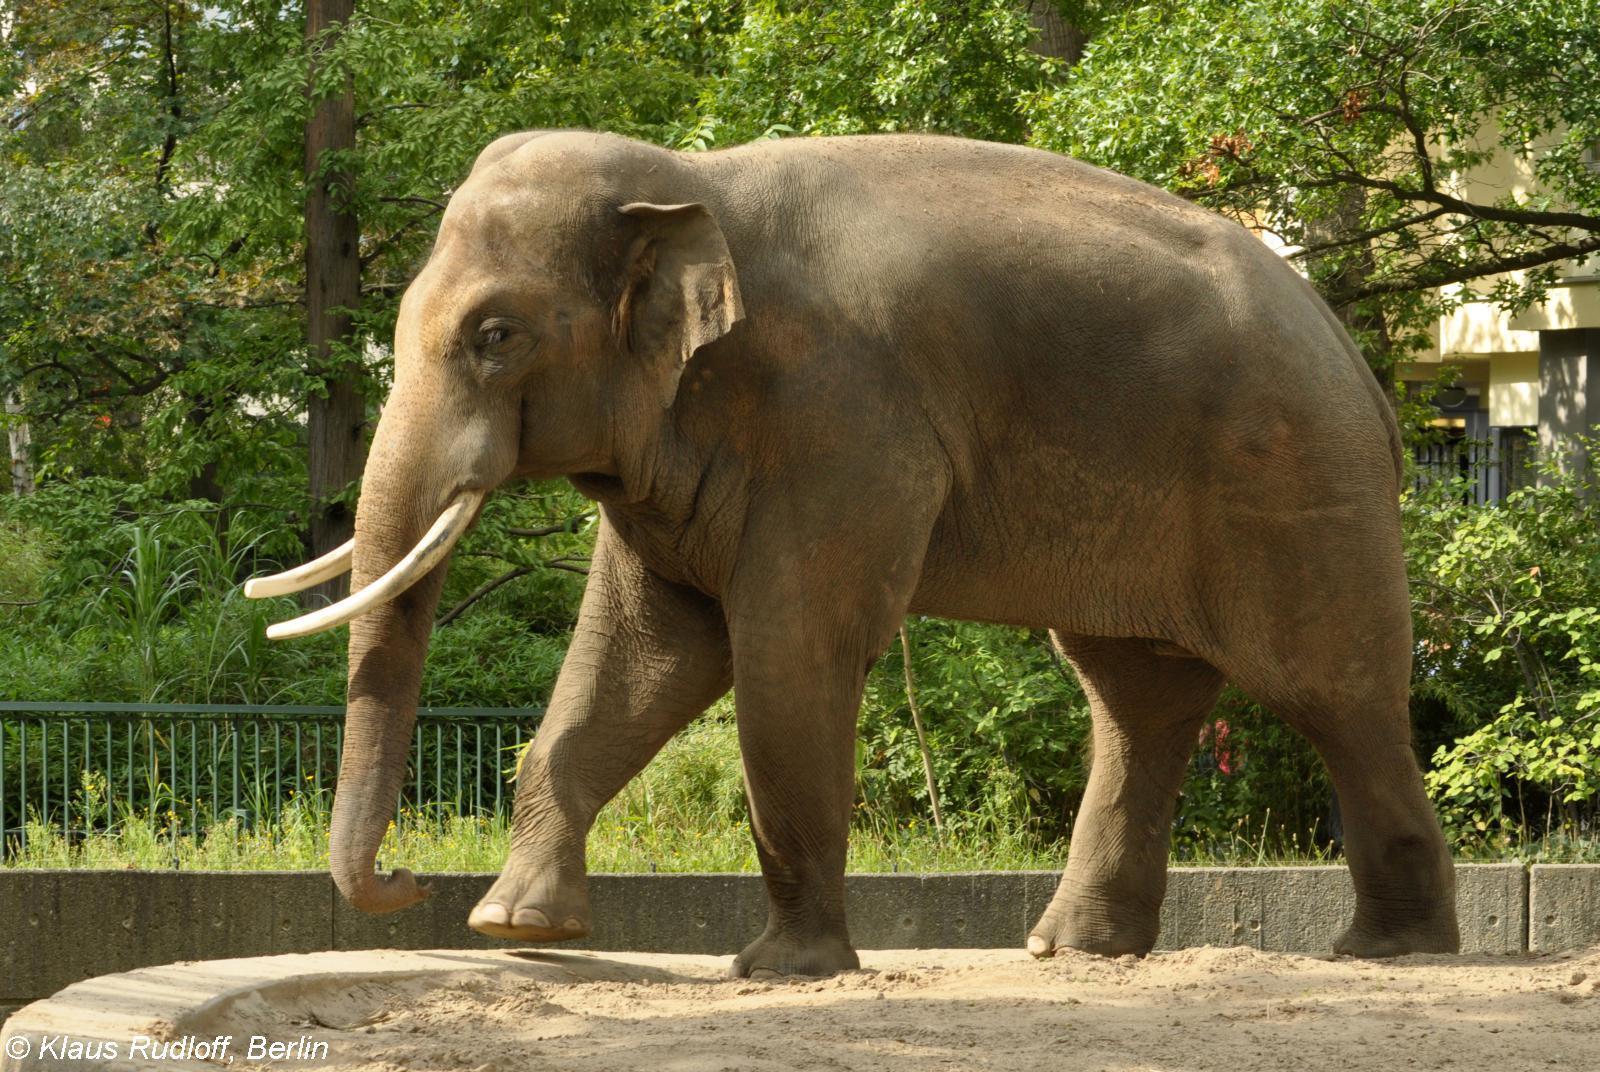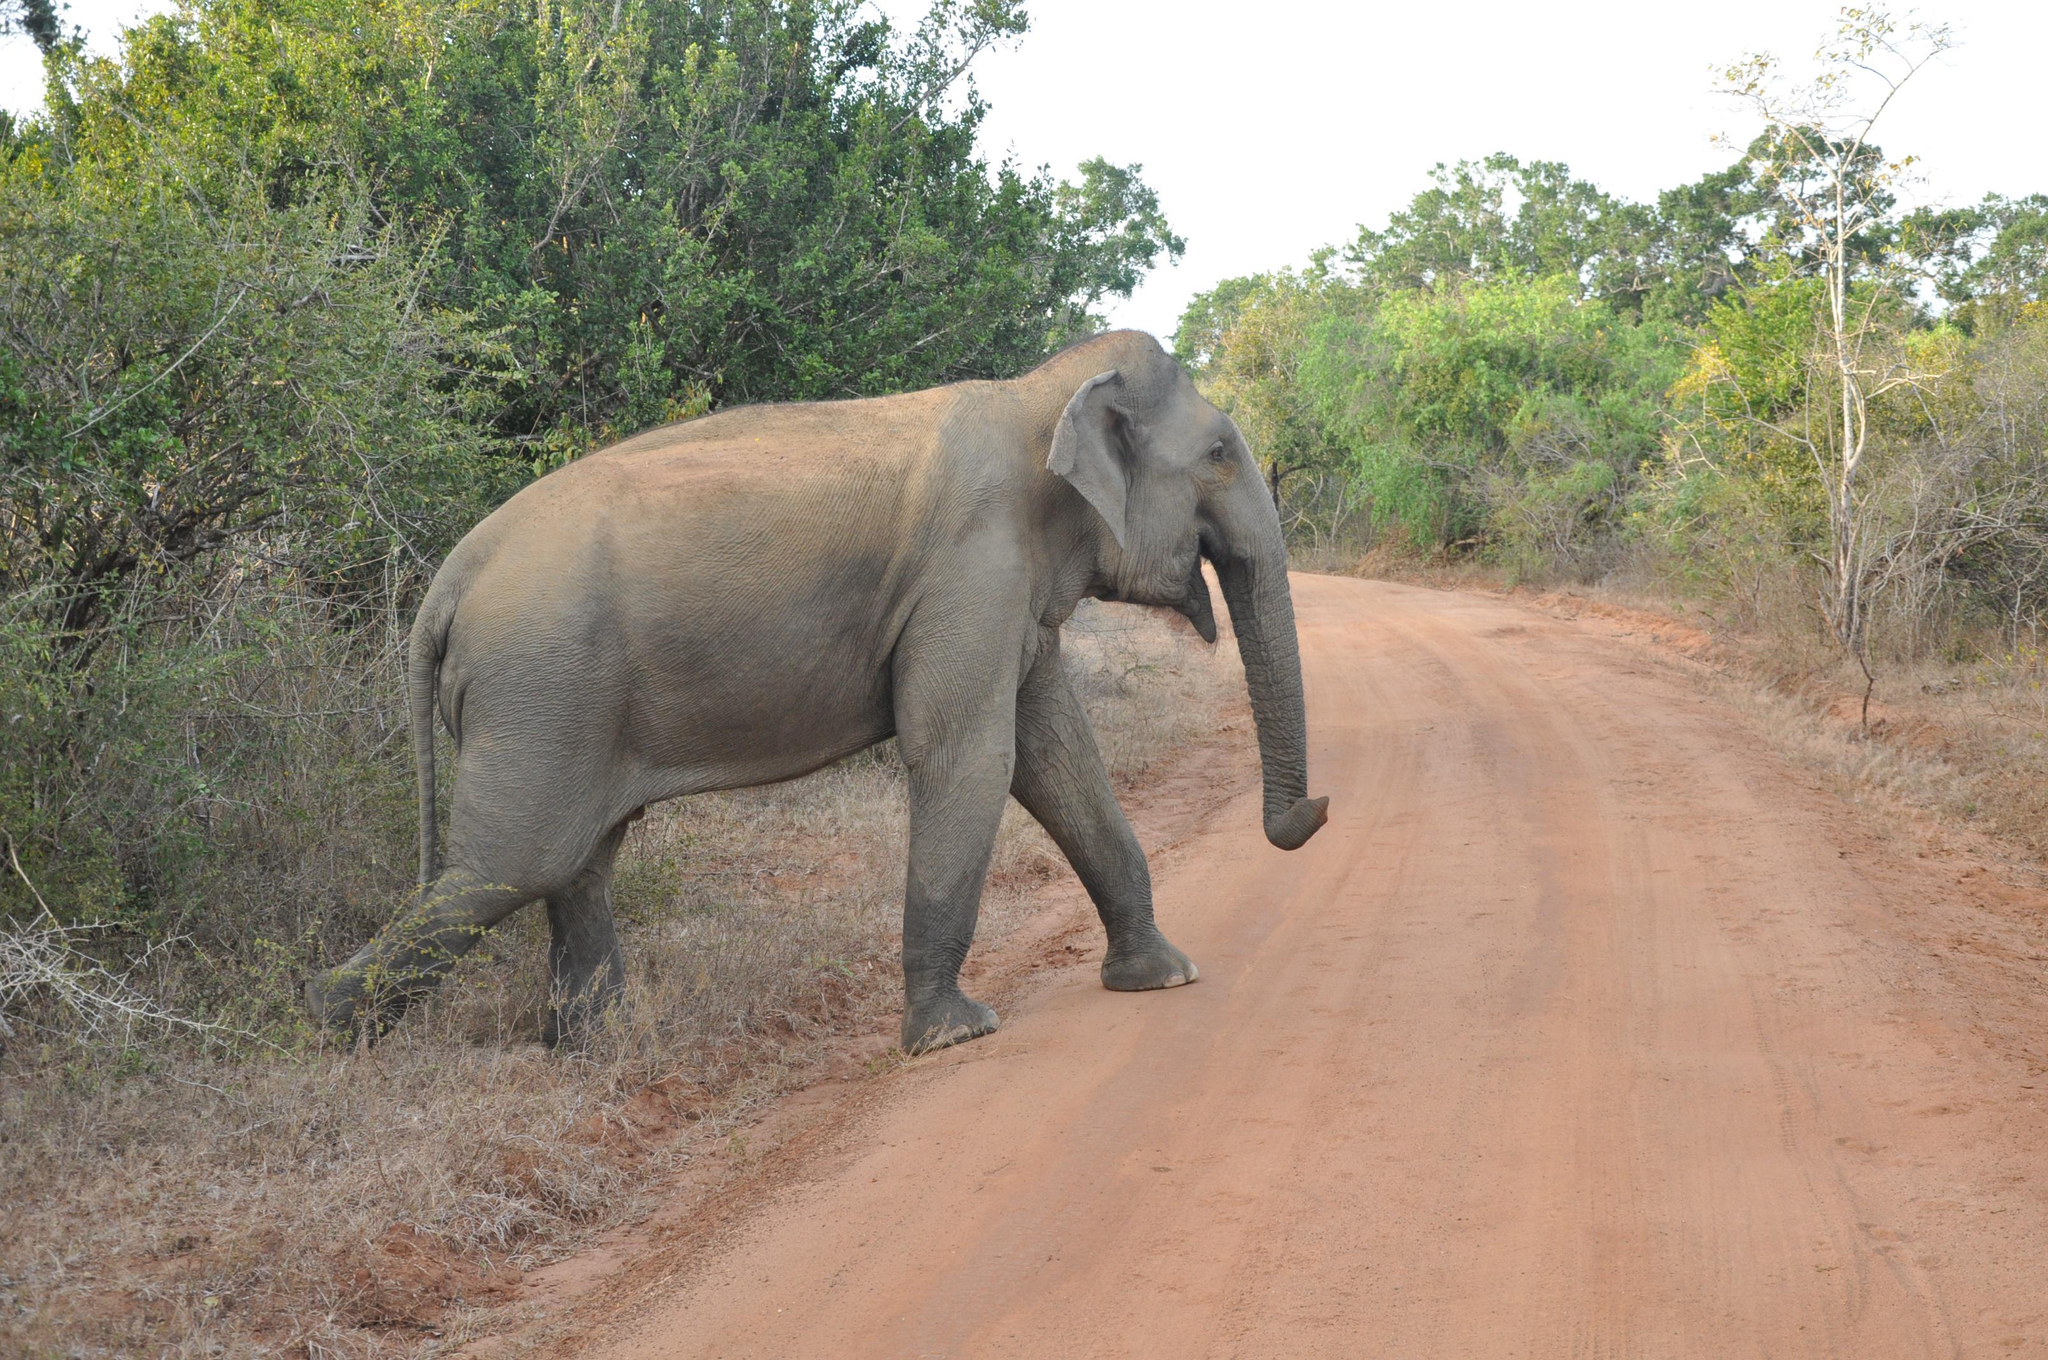The first image is the image on the left, the second image is the image on the right. Analyze the images presented: Is the assertion "There is exactly two elephants in the right image." valid? Answer yes or no. No. The first image is the image on the left, the second image is the image on the right. Evaluate the accuracy of this statement regarding the images: "The left image shows one lone adult elephant, while the right image shows one adult elephant with one younger elephant beside it". Is it true? Answer yes or no. No. 